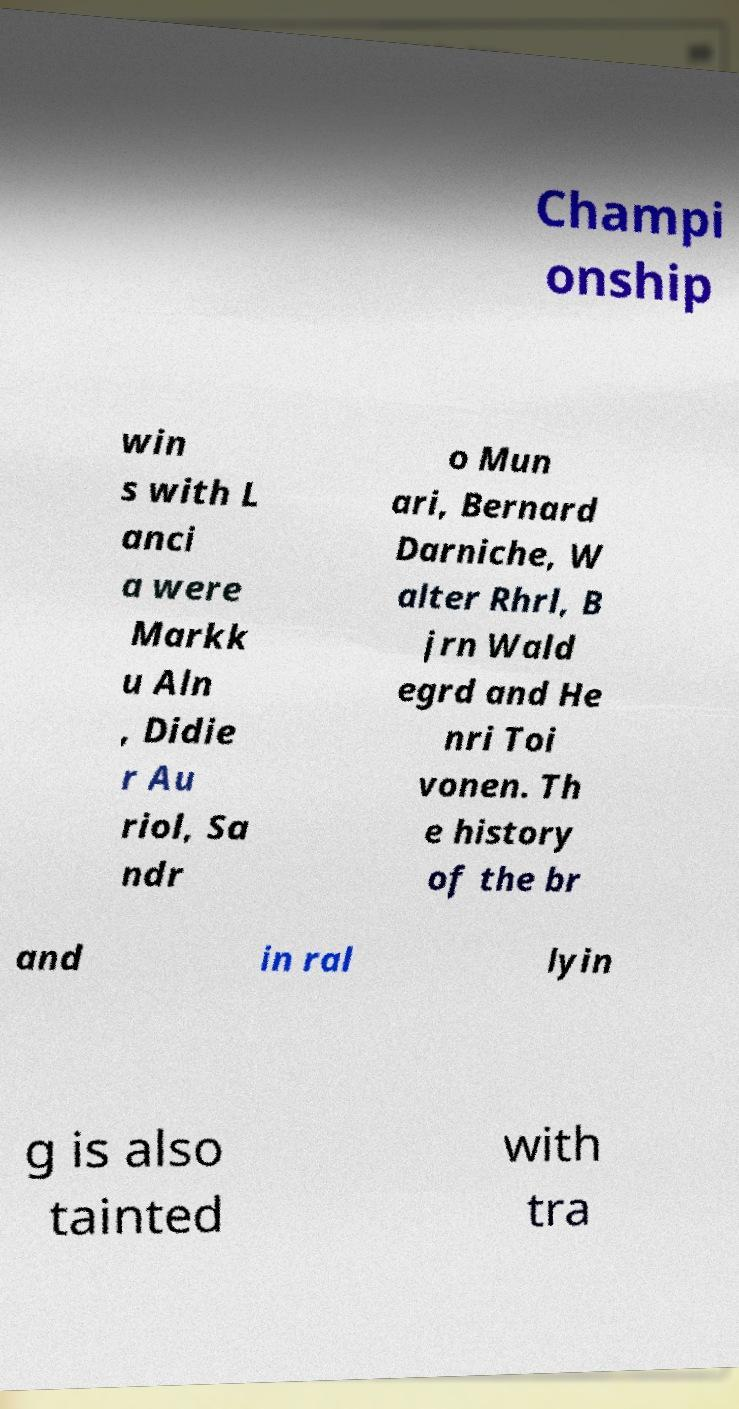What messages or text are displayed in this image? I need them in a readable, typed format. Champi onship win s with L anci a were Markk u Aln , Didie r Au riol, Sa ndr o Mun ari, Bernard Darniche, W alter Rhrl, B jrn Wald egrd and He nri Toi vonen. Th e history of the br and in ral lyin g is also tainted with tra 